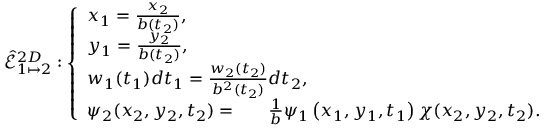Convert formula to latex. <formula><loc_0><loc_0><loc_500><loc_500>\hat { \mathcal { E } } _ { 1 \mapsto 2 } ^ { 2 D } \colon \left \{ \begin{array} { l l } { x _ { 1 } = \frac { x _ { 2 } } { b ( t _ { 2 } ) } , } \\ { y _ { 1 } = \frac { y _ { 2 } } { b ( t _ { 2 } ) } , } \\ { w _ { 1 } ( t _ { 1 } ) d t _ { 1 } = \frac { w _ { 2 } ( t _ { 2 } ) } { b ^ { 2 } ( t _ { 2 } ) } d t _ { 2 } , } \\ { \psi _ { 2 } ( x _ { 2 } , y _ { 2 } , t _ { 2 } ) = \ \frac { 1 } { b } \psi _ { 1 } \left ( x _ { 1 } , y _ { 1 } , t _ { 1 } \right ) \chi ( x _ { 2 } , y _ { 2 } , t _ { 2 } ) . } \end{array}</formula> 